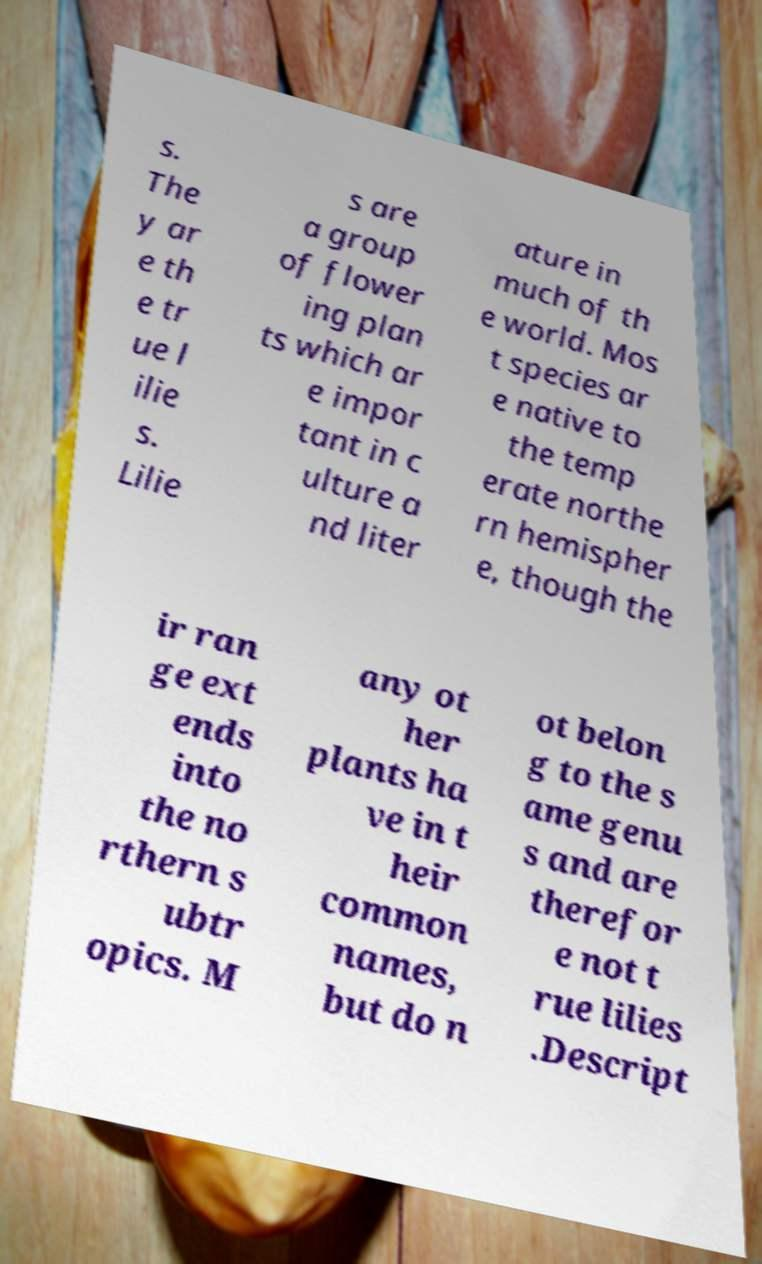Can you accurately transcribe the text from the provided image for me? s. The y ar e th e tr ue l ilie s. Lilie s are a group of flower ing plan ts which ar e impor tant in c ulture a nd liter ature in much of th e world. Mos t species ar e native to the temp erate northe rn hemispher e, though the ir ran ge ext ends into the no rthern s ubtr opics. M any ot her plants ha ve in t heir common names, but do n ot belon g to the s ame genu s and are therefor e not t rue lilies .Descript 